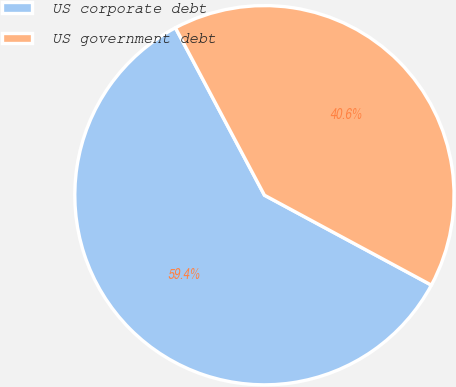Convert chart to OTSL. <chart><loc_0><loc_0><loc_500><loc_500><pie_chart><fcel>US corporate debt<fcel>US government debt<nl><fcel>59.36%<fcel>40.64%<nl></chart> 